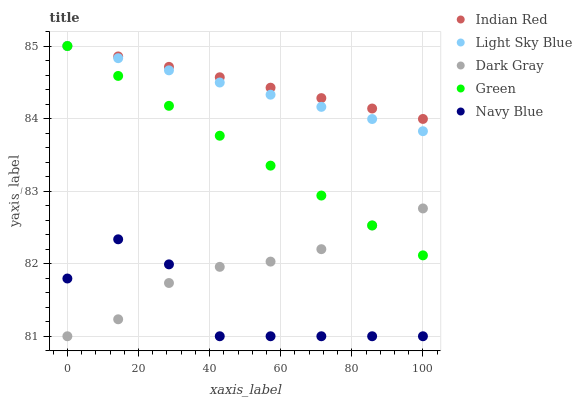Does Navy Blue have the minimum area under the curve?
Answer yes or no. Yes. Does Indian Red have the maximum area under the curve?
Answer yes or no. Yes. Does Light Sky Blue have the minimum area under the curve?
Answer yes or no. No. Does Light Sky Blue have the maximum area under the curve?
Answer yes or no. No. Is Green the smoothest?
Answer yes or no. Yes. Is Navy Blue the roughest?
Answer yes or no. Yes. Is Light Sky Blue the smoothest?
Answer yes or no. No. Is Light Sky Blue the roughest?
Answer yes or no. No. Does Dark Gray have the lowest value?
Answer yes or no. Yes. Does Light Sky Blue have the lowest value?
Answer yes or no. No. Does Indian Red have the highest value?
Answer yes or no. Yes. Does Navy Blue have the highest value?
Answer yes or no. No. Is Navy Blue less than Indian Red?
Answer yes or no. Yes. Is Green greater than Navy Blue?
Answer yes or no. Yes. Does Navy Blue intersect Dark Gray?
Answer yes or no. Yes. Is Navy Blue less than Dark Gray?
Answer yes or no. No. Is Navy Blue greater than Dark Gray?
Answer yes or no. No. Does Navy Blue intersect Indian Red?
Answer yes or no. No. 